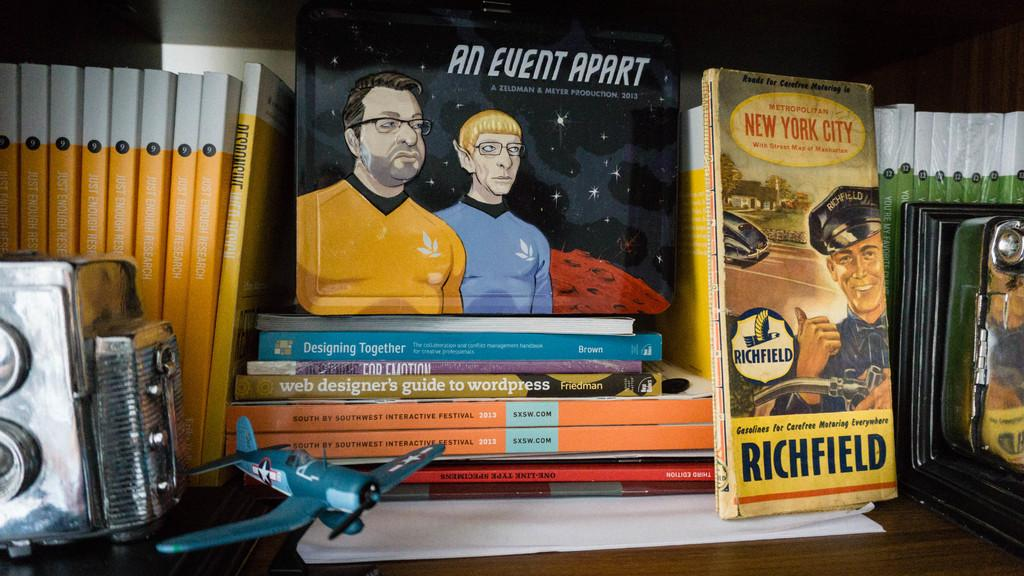<image>
Relay a brief, clear account of the picture shown. Several books are stacked including a book called An event apart and one called Richfield. 